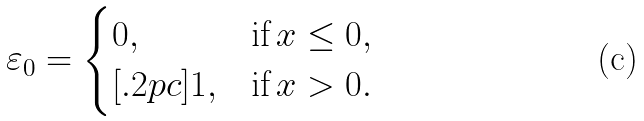Convert formula to latex. <formula><loc_0><loc_0><loc_500><loc_500>\varepsilon _ { 0 } = \begin{cases} 0 , & \text {if} \, x \leq 0 , \\ [ . 2 p c ] 1 , & \text {if} \, x > 0 . \end{cases}</formula> 